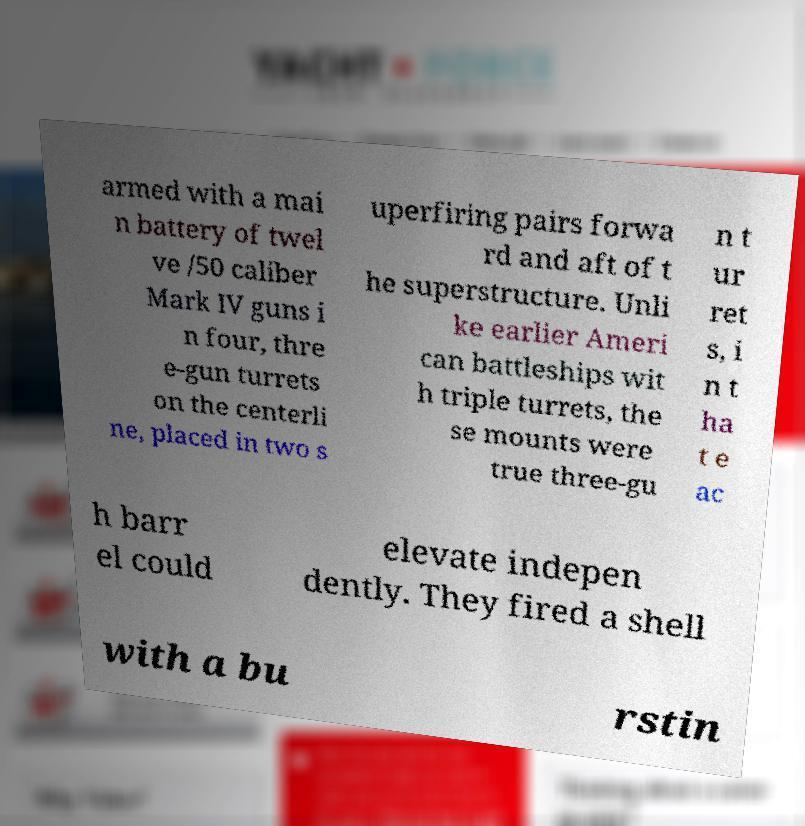Could you extract and type out the text from this image? armed with a mai n battery of twel ve /50 caliber Mark IV guns i n four, thre e-gun turrets on the centerli ne, placed in two s uperfiring pairs forwa rd and aft of t he superstructure. Unli ke earlier Ameri can battleships wit h triple turrets, the se mounts were true three-gu n t ur ret s, i n t ha t e ac h barr el could elevate indepen dently. They fired a shell with a bu rstin 